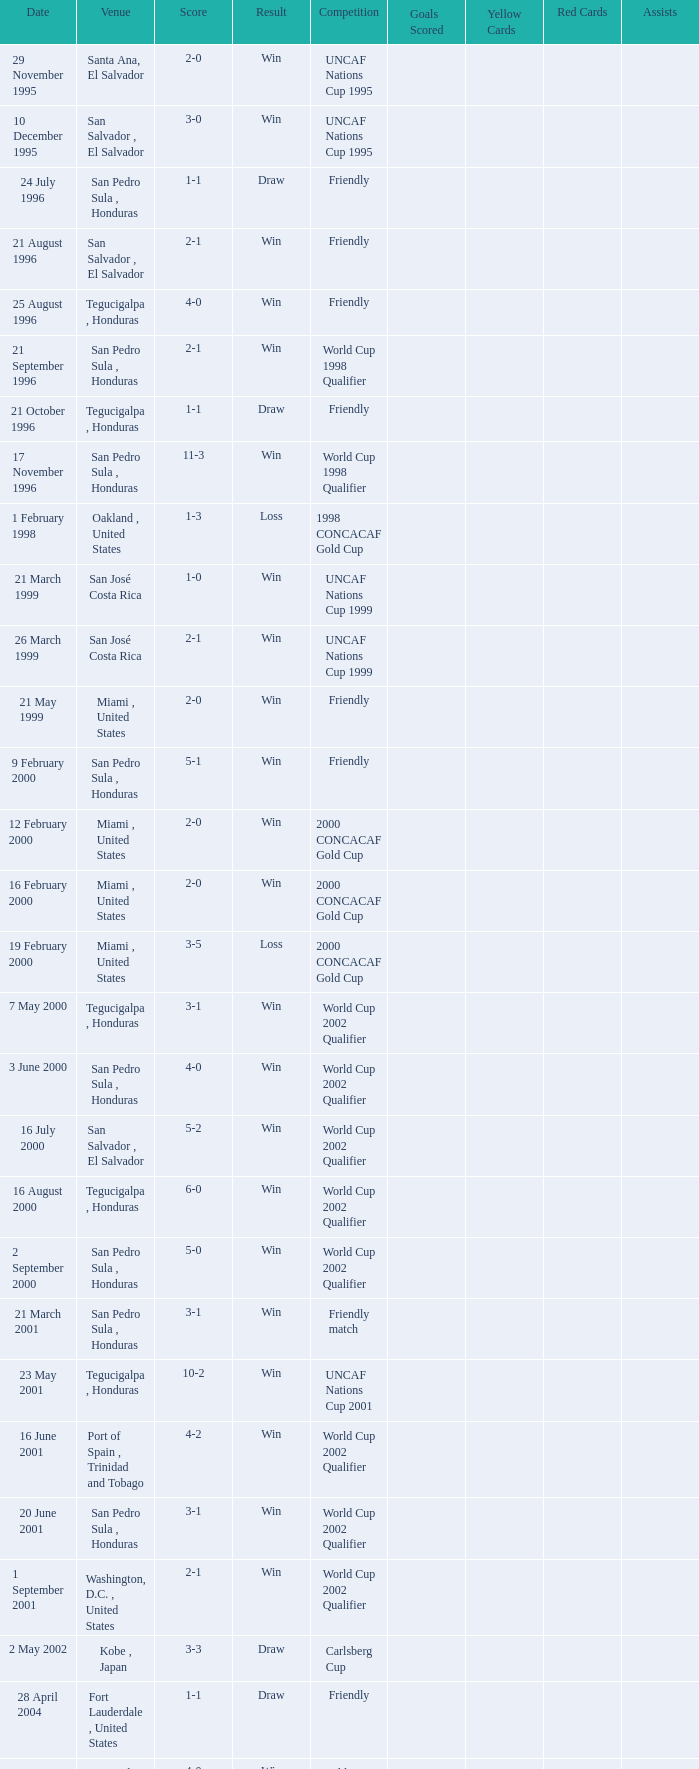What is the location for the amicable contest and result of 4-0? Tegucigalpa , Honduras. 